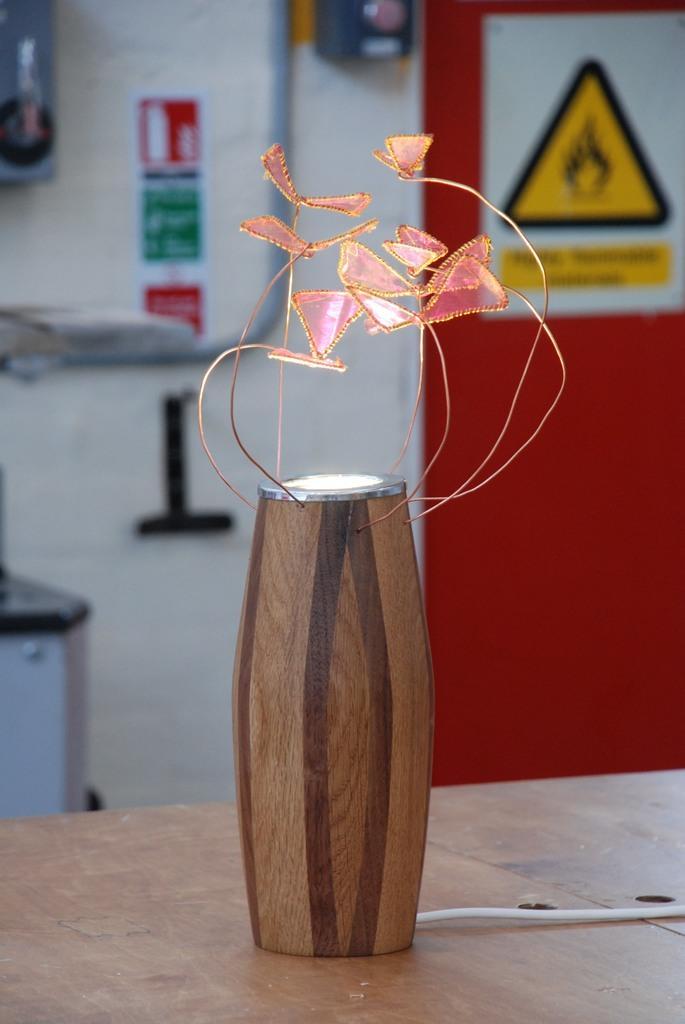In one or two sentences, can you explain what this image depicts? This image is taken indoors. In the background there is a wall with a pipeline and there is a board with a text on it. At the bottom of the image there is a table with a wooden stand on it and there are a few artificial flowers on the wooden stand. 